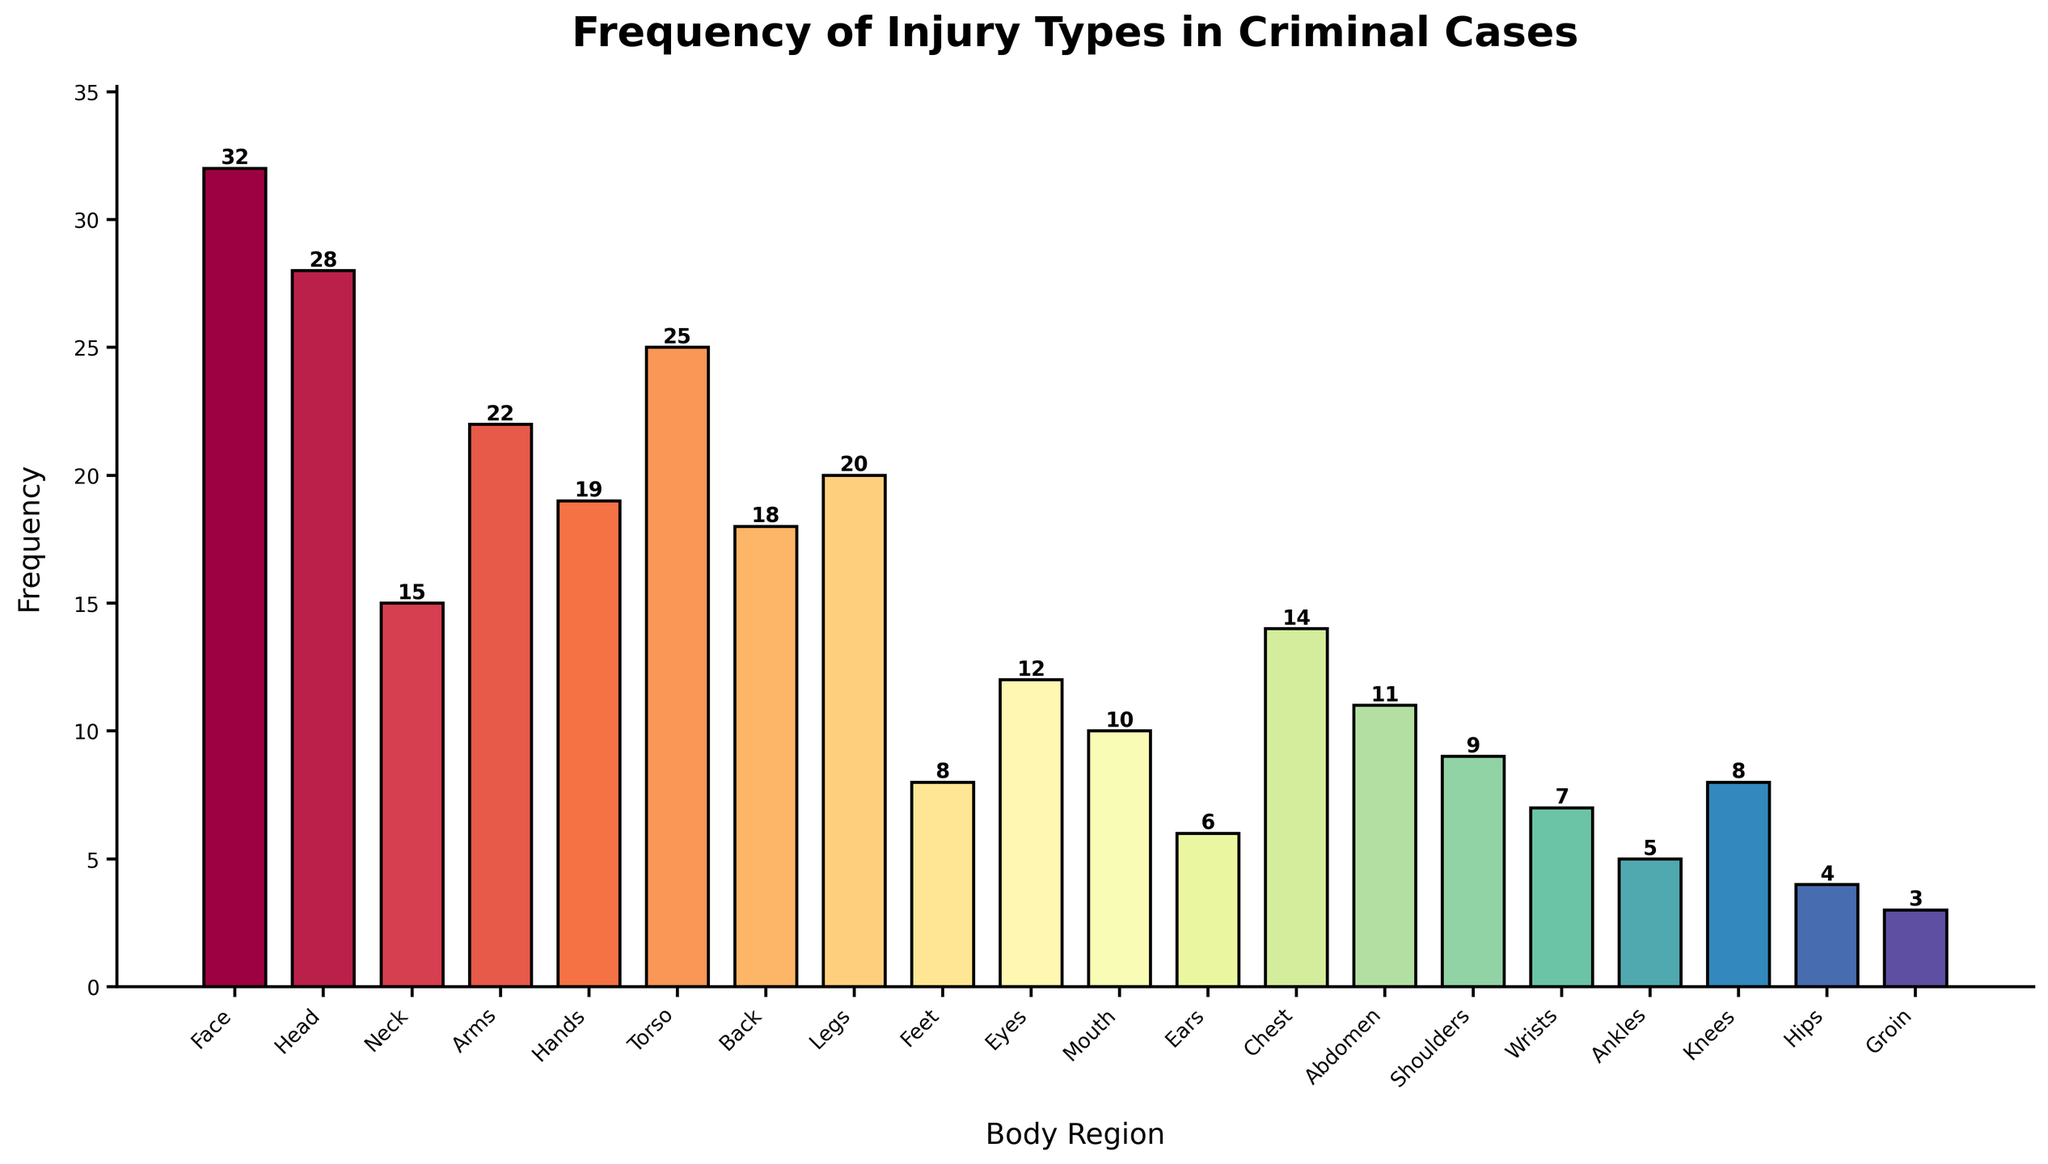What's the most frequent injury type by body region? Look for the tallest bar, which indicates the highest frequency. The bar for "Face" is the tallest.
Answer: Face Which body region showed injuries exactly twice as frequently as the Groin? Find the frequency of injuries for Groin, which is 3. Then find the body region with a frequency of 3*2 = 6. The "Ears" region shows 6 injuries.
Answer: Ears What's the total frequency of injuries for Hands, Feet, and Mouth combined? Sum the frequencies for Hands (19), Feet (8), and Mouth (10). 19 + 8 + 10 = 37
Answer: 37 Which body region has more injuries: Eyes or Wrists? Compare the height of the bars for Eyes and Wrists. Eyes have a frequency of 12, while Wrists have 7. Eyes are higher.
Answer: Eyes What is the difference in frequency between injuries to the Torso and the Chest? Subtract the frequency of the Chest (14) from the frequency of the Torso (25). 25 - 14 = 11
Answer: 11 Are injuries more frequent in the Arms or in the Legs? Compare the two bars. The Arms have a frequency of 22 and the Legs have 20. The Arms bar is taller.
Answer: Arms Which body region has fewer injuries: Ankles or Hips? Compare the bars. Ankles have a frequency of 5 and Hips have a frequency of 4. The Hips bar is lower.
Answer: Hips What is the average frequency of injuries in the Neck, Chest, and Back? Sum the frequencies for Neck (15), Chest (14), and Back (18), then divide by the number of regions. (15 + 14 + 18) / 3 = 47 / 3 ≈ 15.67
Answer: 15.67 What is the combined frequency of injuries for the top three most common body regions? Identify the top three regions: Face (32), Head (28), and Torso (25). Sum their frequencies: 32 + 28 + 25 = 85
Answer: 85 Which body region has an equal number of injuries as the sum of injuries to the Ears and Ankles? Find the frequency of Ears (6) and Ankles (5), then sum them (6+5=11). The Abdomen has a frequency of 11.
Answer: Abdomen 